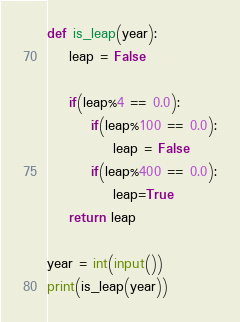Convert code to text. <code><loc_0><loc_0><loc_500><loc_500><_Python_>def is_leap(year):
    leap = False
    
    if(leap%4 == 0.0):
        if(leap%100 == 0.0):
            leap = False
        if(leap%400 == 0.0):
            leap=True
    return leap

year = int(input())
print(is_leap(year))</code> 